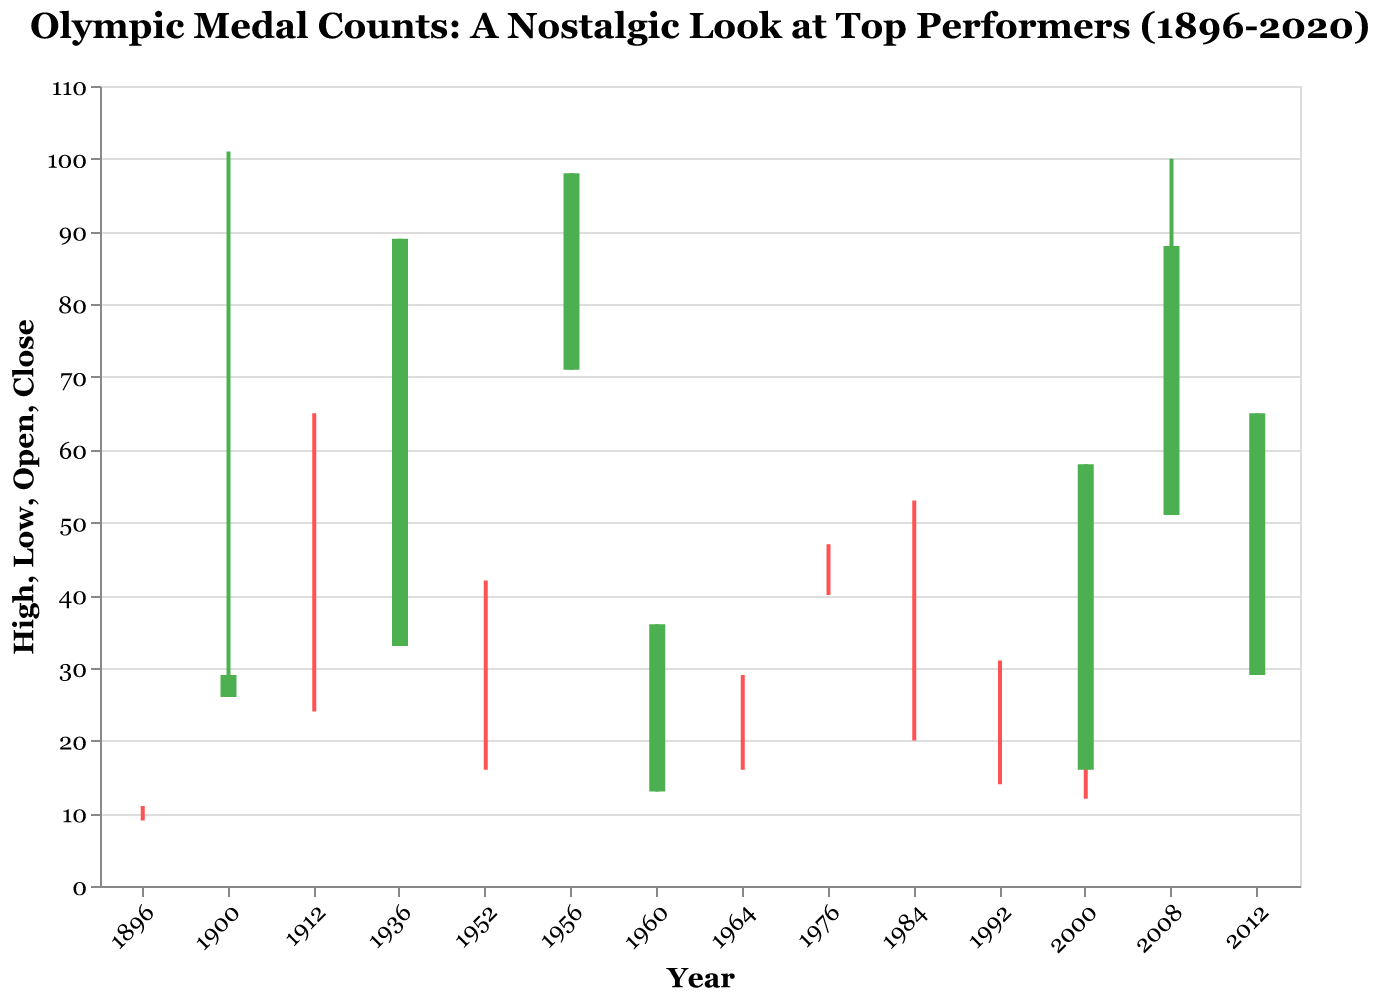What is the title of the figure? The title is usually displayed at the top of the figure, often centered. In this case, the title is written explicitly in the provided description.
Answer: "Olympic Medal Counts: A Nostalgic Look at Top Performers (1896-2020)" Which country has the highest 'High' value on the chart? Look at the "High" values for each data point and find the maximum value. The country with the maximum "High" value is France with a "High" value of 101.
Answer: France What color represents an increase in the total medal count by the end of the period? An increase in the total medal count from "Open" to "Close" is indicated by a specific color. In this figure, the green color indicates an increase.
Answer: Green Which country had the most considerable range (difference between 'High' and 'Low') in medal count? To find the country with the most considerable range, calculate the range for each data point by subtracting the 'Low' value from the 'High' value. France has the highest range of 75 (101 - 26).
Answer: France Which country and year combination saw their "Close" count equal their "Low"? Identify the data points where 'Close' value equals the 'Low' value. These data points are East Germany (1976), Sweden (1912), Japan (1964), Hungary (1952), Netherlands (2000), Cuba (1992), and Romania (1984).
Answer: East Germany (1976), Sweden (1912), Japan (1964), Hungary (1952), Netherlands (2000), Cuba (1992), Romania (1984) How many countries reached a 'High' value greater than or equal to 60? Count the number of times the 'High' value for any country is 60 or more. The count includes France (101), Soviet Union (98), China (100), Germany (89), and Great Britain (65). There are 5 such instances.
Answer: 5 Calculate the average 'Open' value for the countries that participated before 1950. First, identify the countries that participated before 1950: United States (1896), France (1900), Sweden (1912), and Germany (1936). Then, sum up their 'Open' values and divide by the number of countries: (11 + 26 + 24 + 33) / 4. The sum is 94, and the average is 94 / 4 = 23.5
Answer: 23.5 What is the difference in 'High' values between China (2008) and the United States (1896)? Find the 'High' values for China (100) and the United States (11). Then subtract the 'High' value of the United States from that of China: 100 - 11 = 89.
Answer: 89 Between which two countries did the Close value increase from the Open value the most? Calculate the difference between 'Close' and 'Open' for each country and compare the differences. China saw an increase from 51 to 88 (difference of 37), and Great Britain saw an increase from 29 to 65 (difference of 36). China has the largest increase.
Answer: China (51 to 88) Which country saw no difference between its 'Open' and 'Close' values and also didn't surpass a 'High' of 30? Look for countries where 'Open' equals 'Close' and 'High' does not exceed 30. Sweden (1912), Japan (1964), Hungary (1952), Netherlands (2000), Cuba (1992), and Romania (1984) have equal 'Open' and 'Close'. Among these, Netherlands and Japan have 'High' values under 30.
Answer: Netherlands, Japan 